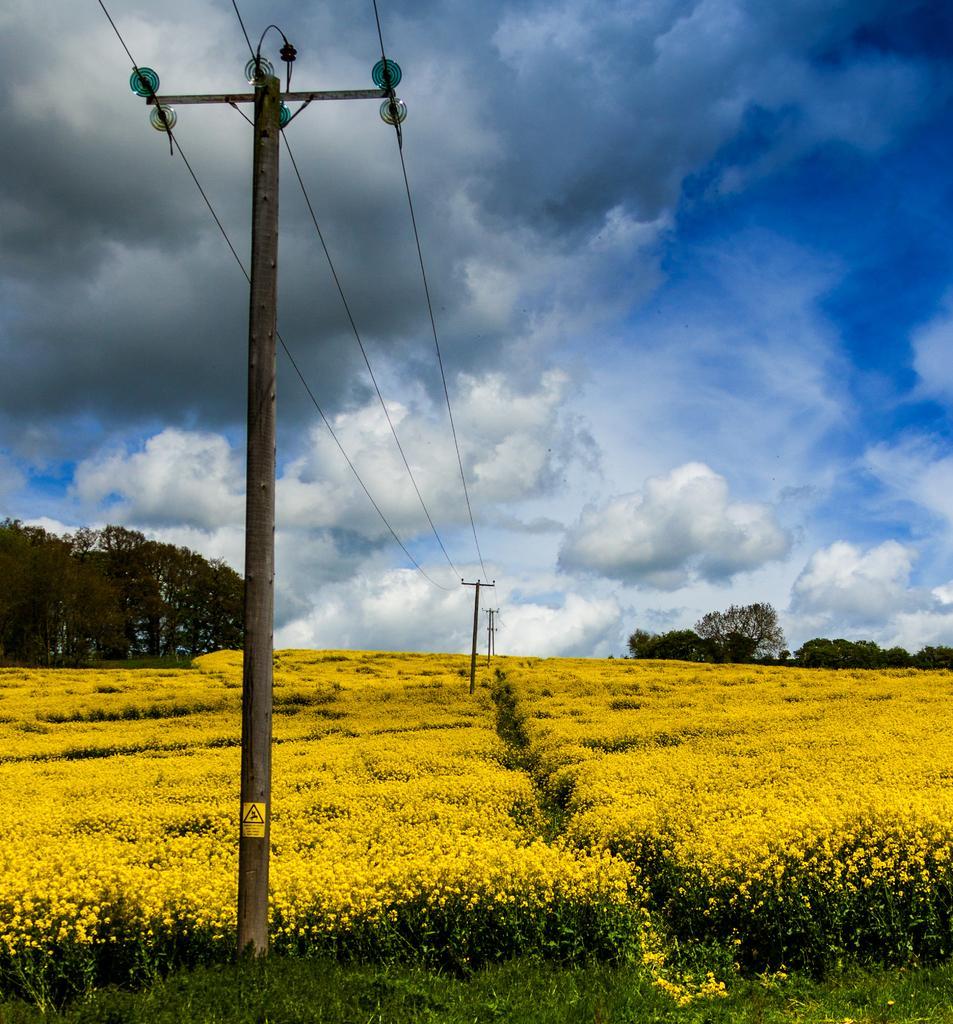Please provide a concise description of this image. In this image, at the left side there is an electric pole, there are some cables passing from the pole, there are some yellow color flowers, at the top there is a blue color sky and there are some white color clouds. 